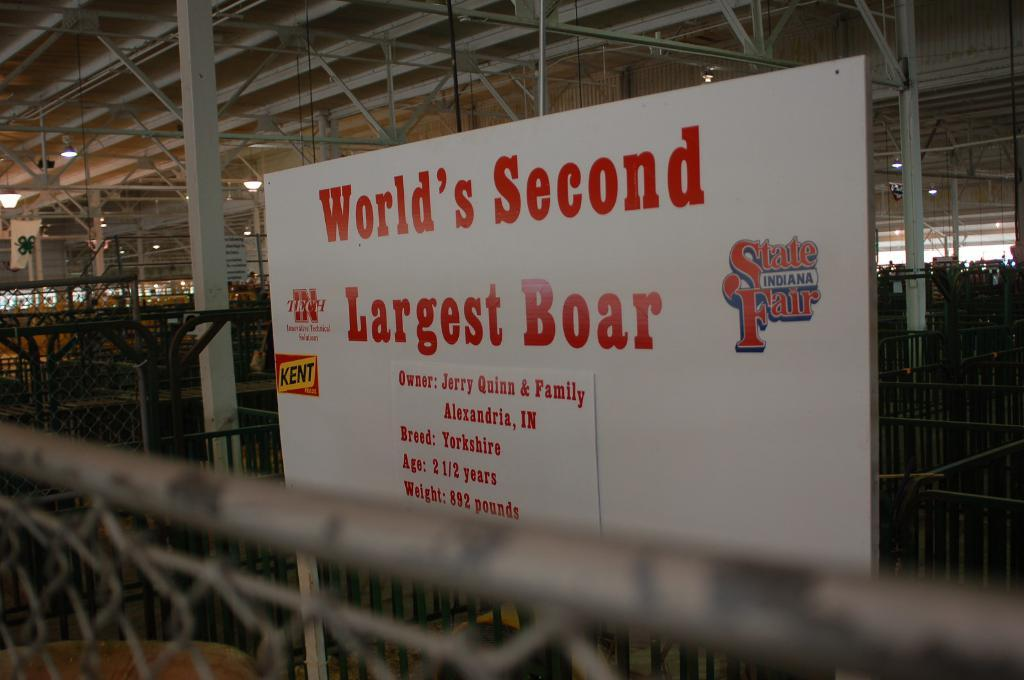Provide a one-sentence caption for the provided image. A sign reads "World's Second Largest Boar" at the Indiana State Fair. 